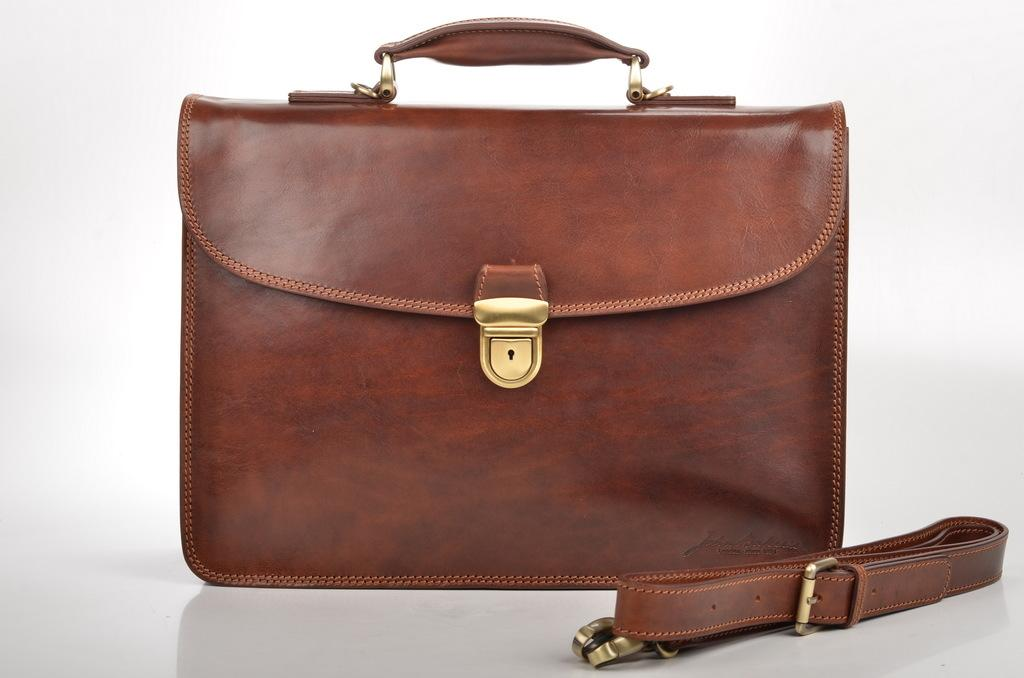What is the color of the bag in the image? The bag in the image is brown. How is the bag carried in the image? The bag has a belt handle for carrying. Is there any security feature on the bag? Yes, the bag has a lock on it. How many sisters are depicted in the image with the bag? There are no sisters present in the image; it only features the bag. Is there a harbor visible in the image? There is no harbor present in the image. 